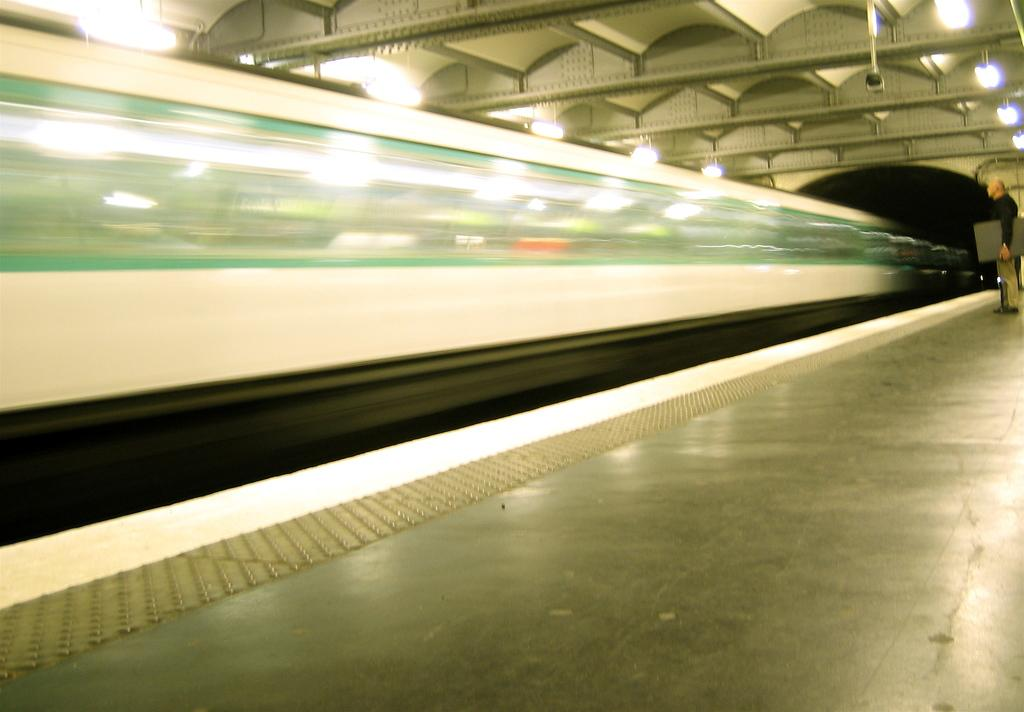What is the man doing on the right side of the image? The man is standing on the right side of the image. What is the man holding in his hand? The man is holding an object that is grey in color. What can be seen at the top of the image? There are lights visible at the top of the image. How would you describe the image on the left side? The image on the left side is blurry. What type of treatment is the farmer receiving in the image? There is no farmer or treatment present in the image. 